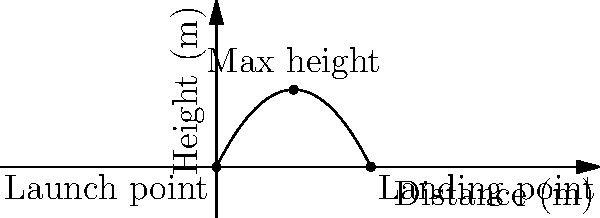In a physics lab experiment demonstrating projectile motion, a ball is launched from ground level and follows the parabolic trajectory shown in the graph. If the ball reaches a maximum height of 4 meters, what is the total horizontal distance traveled by the ball before it lands? To solve this problem, we'll use the symmetry of the parabolic trajectory:

1) The parabola represents the path of the projectile.
2) The highest point of the parabola (vertex) occurs at the midpoint of the horizontal distance.
3) The maximum height is reached at this midpoint.

From the graph, we can see:
- The maximum height is 4 meters
- This occurs at the midpoint of the horizontal distance

Let's analyze:
1) If the midpoint occurs at 4 meters horizontally (where the max height is reached)
2) And this is half of the total horizontal distance
3) Then the total horizontal distance must be twice this value

Therefore:
Total horizontal distance = 2 * (distance to max height)
                          = 2 * 4 meters
                          = 8 meters

This matches with the landing point shown on the x-axis of the graph.
Answer: 8 meters 